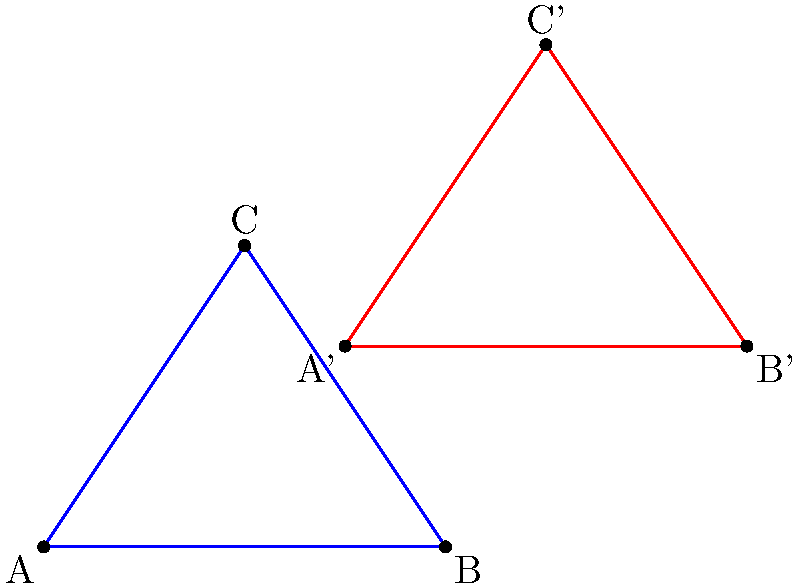In the coordinate plane above, triangle ABC (blue) has been transformed to triangle A'B'C' (red). If the transformation involves a translation followed by a rotation about the origin, determine the translation vector and the angle of rotation. Let's approach this step-by-step:

1) First, we need to find the translation vector:
   - We can do this by comparing any corresponding point before and after the translation.
   - Let's use point A (-2,0) and A' (1,2).
   - The translation vector is: $\vec{v} = A' - A = (1,2) - (-2,0) = (3,2)$

2) Now, we need to "undo" the translation to isolate the rotation:
   - Subtract (3,2) from all points of A'B'C':
     A": (1,2) - (3,2) = (-2,0)
     B": (5,2) - (3,2) = (2,0)
     C": (3,5) - (3,2) = (0,3)

3) We can see that A"B"C" is identical to ABC, which confirms our translation.

4) To find the rotation angle, we can use the angle between AC and A'C':
   - Vector AC: (0,3) - (-2,0) = (2,3)
   - Vector A'C': (3,5) - (1,2) = (2,3)

5) These vectors are the same, which means there was no rotation.

Therefore, the transformation was a pure translation with no rotation.
Answer: Translation vector: (3,2), Rotation angle: 0° 